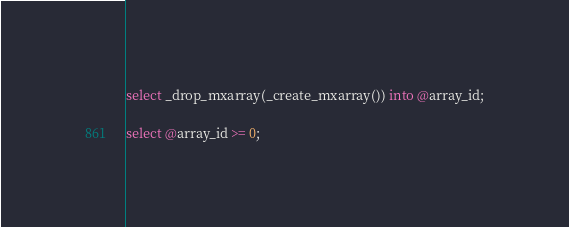<code> <loc_0><loc_0><loc_500><loc_500><_SQL_>select _drop_mxarray(_create_mxarray()) into @array_id;

select @array_id >= 0;
</code> 